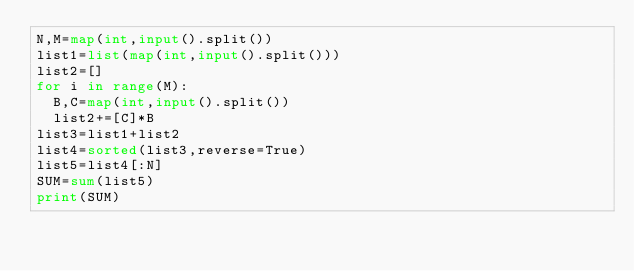<code> <loc_0><loc_0><loc_500><loc_500><_Python_>N,M=map(int,input().split())
list1=list(map(int,input().split()))
list2=[]
for i in range(M):
  B,C=map(int,input().split())
  list2+=[C]*B
list3=list1+list2
list4=sorted(list3,reverse=True)
list5=list4[:N]
SUM=sum(list5)
print(SUM)</code> 